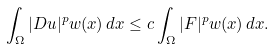Convert formula to latex. <formula><loc_0><loc_0><loc_500><loc_500>\int _ { \Omega } | D u | ^ { p } w ( x ) \, d x \leq c \int _ { \Omega } | F | ^ { p } w ( x ) \, d x .</formula> 